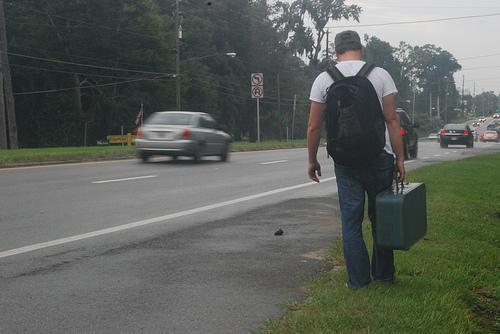How many suitcases does the man hold?
Give a very brief answer. 1. 